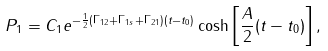Convert formula to latex. <formula><loc_0><loc_0><loc_500><loc_500>P _ { 1 } = C _ { 1 } e ^ { - \frac { 1 } { 2 } ( \Gamma _ { 1 2 } + \Gamma _ { 1 s } + \Gamma _ { 2 1 } ) ( t - t _ { 0 } ) } \cosh \left [ \frac { A } { 2 } ( t - t _ { 0 } ) \right ] ,</formula> 